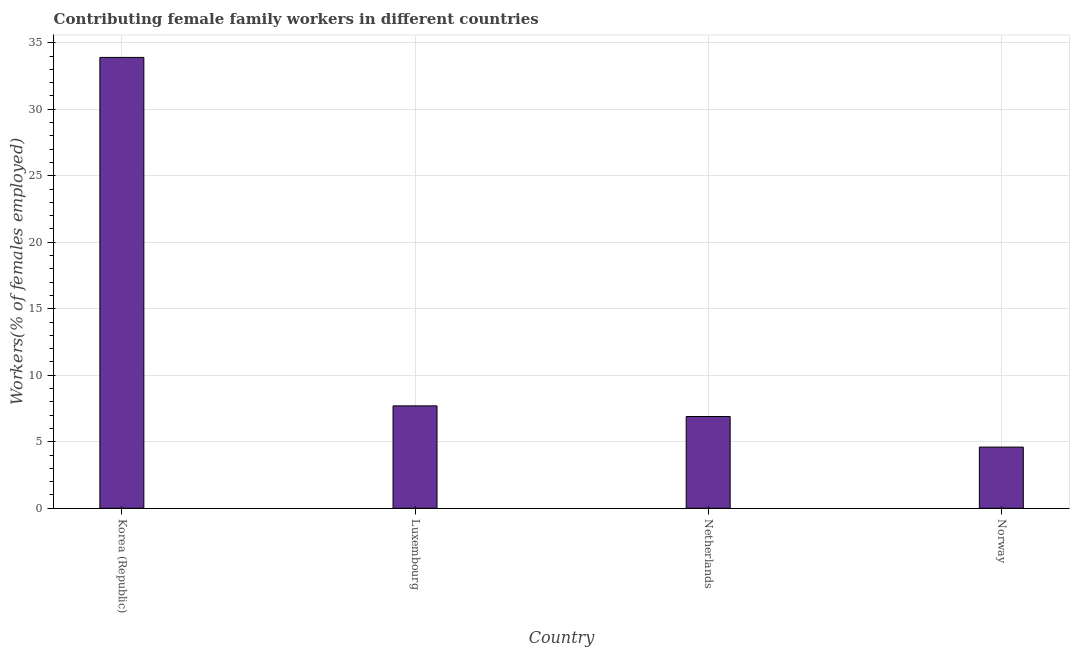Does the graph contain any zero values?
Offer a very short reply. No. What is the title of the graph?
Give a very brief answer. Contributing female family workers in different countries. What is the label or title of the Y-axis?
Your answer should be compact. Workers(% of females employed). What is the contributing female family workers in Korea (Republic)?
Your answer should be compact. 33.9. Across all countries, what is the maximum contributing female family workers?
Your answer should be very brief. 33.9. Across all countries, what is the minimum contributing female family workers?
Make the answer very short. 4.6. In which country was the contributing female family workers maximum?
Provide a short and direct response. Korea (Republic). In which country was the contributing female family workers minimum?
Your response must be concise. Norway. What is the sum of the contributing female family workers?
Provide a succinct answer. 53.1. What is the average contributing female family workers per country?
Give a very brief answer. 13.28. What is the median contributing female family workers?
Offer a terse response. 7.3. What is the ratio of the contributing female family workers in Luxembourg to that in Netherlands?
Make the answer very short. 1.12. Is the difference between the contributing female family workers in Luxembourg and Netherlands greater than the difference between any two countries?
Make the answer very short. No. What is the difference between the highest and the second highest contributing female family workers?
Keep it short and to the point. 26.2. What is the difference between the highest and the lowest contributing female family workers?
Your response must be concise. 29.3. In how many countries, is the contributing female family workers greater than the average contributing female family workers taken over all countries?
Offer a very short reply. 1. What is the Workers(% of females employed) of Korea (Republic)?
Provide a short and direct response. 33.9. What is the Workers(% of females employed) in Luxembourg?
Ensure brevity in your answer.  7.7. What is the Workers(% of females employed) of Netherlands?
Keep it short and to the point. 6.9. What is the Workers(% of females employed) of Norway?
Provide a short and direct response. 4.6. What is the difference between the Workers(% of females employed) in Korea (Republic) and Luxembourg?
Give a very brief answer. 26.2. What is the difference between the Workers(% of females employed) in Korea (Republic) and Norway?
Offer a very short reply. 29.3. What is the difference between the Workers(% of females employed) in Luxembourg and Netherlands?
Make the answer very short. 0.8. What is the difference between the Workers(% of females employed) in Netherlands and Norway?
Offer a terse response. 2.3. What is the ratio of the Workers(% of females employed) in Korea (Republic) to that in Luxembourg?
Provide a short and direct response. 4.4. What is the ratio of the Workers(% of females employed) in Korea (Republic) to that in Netherlands?
Make the answer very short. 4.91. What is the ratio of the Workers(% of females employed) in Korea (Republic) to that in Norway?
Ensure brevity in your answer.  7.37. What is the ratio of the Workers(% of females employed) in Luxembourg to that in Netherlands?
Your response must be concise. 1.12. What is the ratio of the Workers(% of females employed) in Luxembourg to that in Norway?
Your response must be concise. 1.67. 